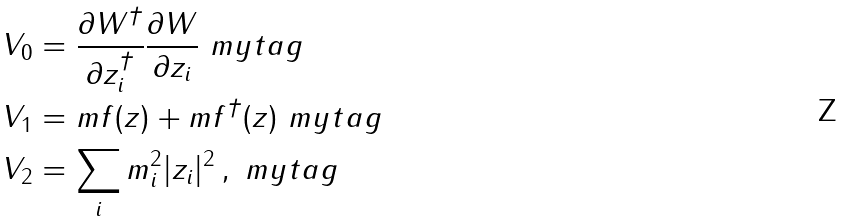<formula> <loc_0><loc_0><loc_500><loc_500>V _ { 0 } & = \frac { \partial W ^ { \dagger } } { \partial z _ { i } ^ { \dagger } } \frac { \partial W } { \partial z _ { i } } \ m y t a g \\ V _ { 1 } & = m f ( z ) + m f ^ { \dagger } ( z ) \ m y t a g \\ V _ { 2 } & = \sum _ { i } m ^ { 2 } _ { i } | z _ { i } | ^ { 2 } \, , \ m y t a g</formula> 